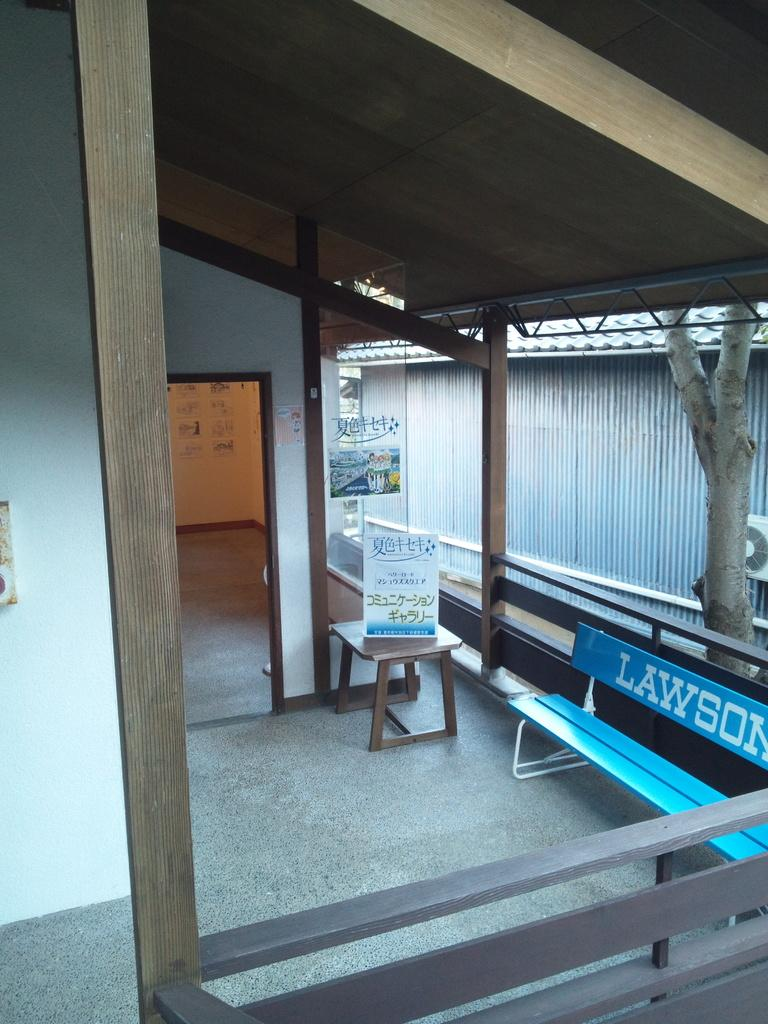<image>
Present a compact description of the photo's key features. blue bench with the words lawson on its back rest. 